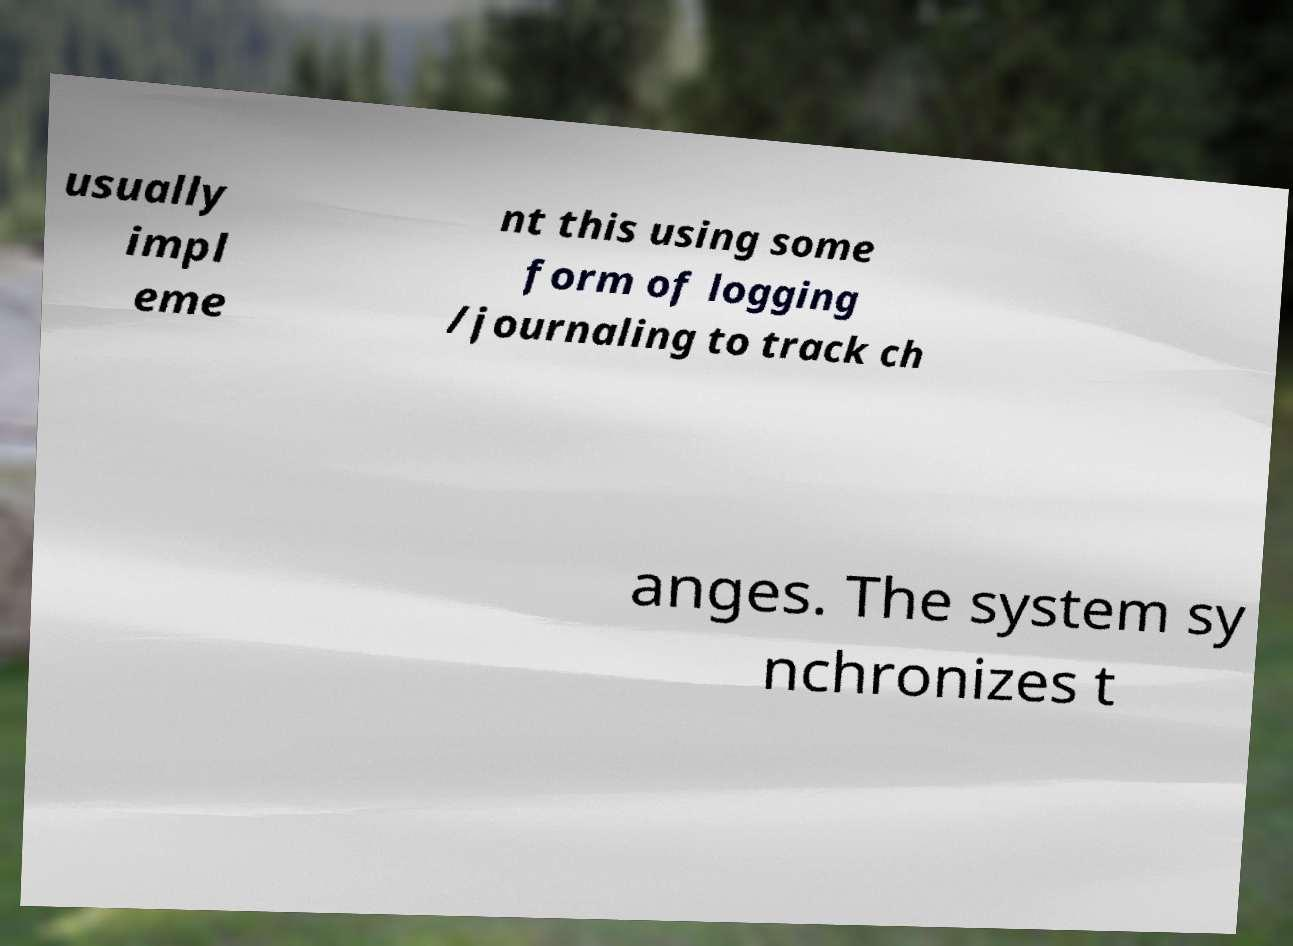Could you assist in decoding the text presented in this image and type it out clearly? usually impl eme nt this using some form of logging /journaling to track ch anges. The system sy nchronizes t 